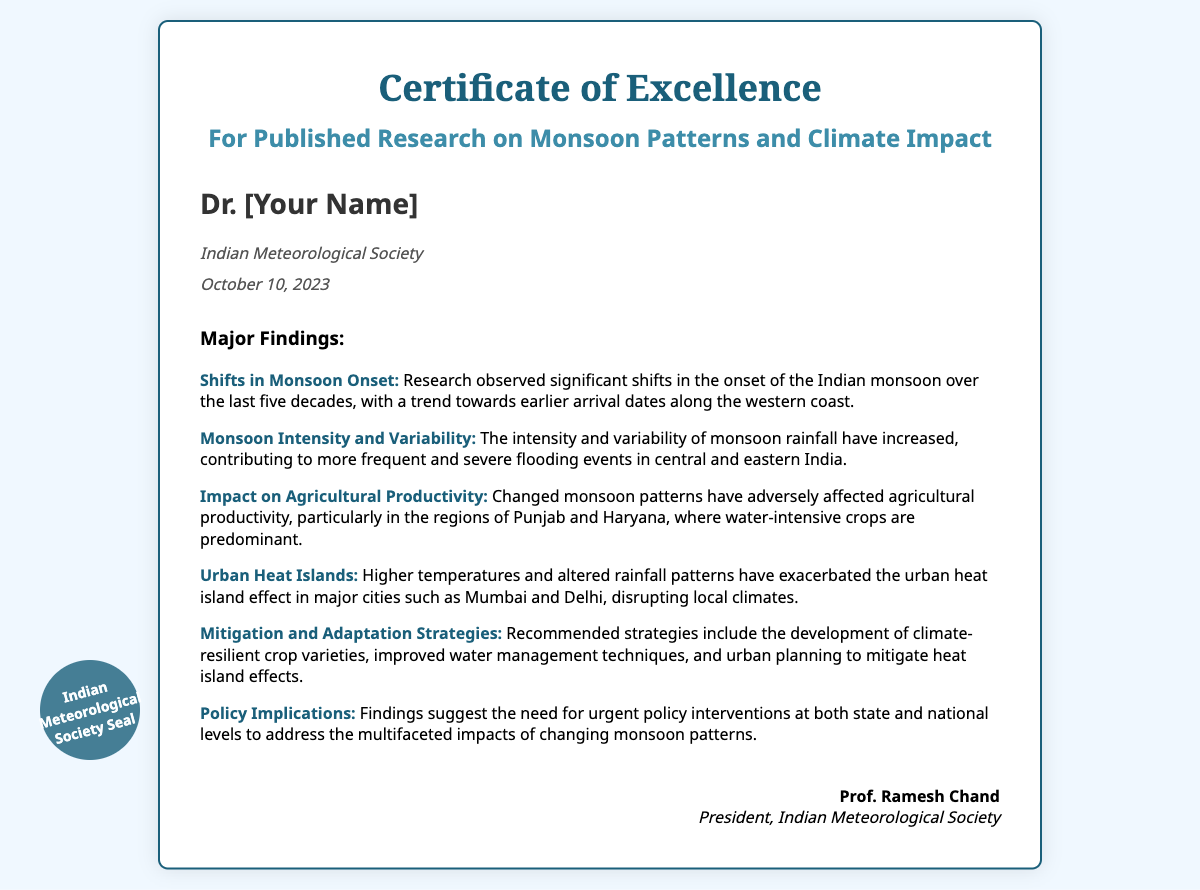What is the title of the certificate? The title of the certificate is prominently displayed at the top of the document, stating its purpose.
Answer: Certificate of Excellence Who is the recipient of the certificate? The recipient's name is clearly stated in the document, indicating who received the award.
Answer: Dr. [Your Name] What organization issued the certificate? The organization that issued the certificate is mentioned below the recipient's name.
Answer: Indian Meteorological Society What date was the certificate issued? The date of issuance is provided in the document, indicating when the certificate was given.
Answer: October 10, 2023 How many major findings are listed in the document? The total number of major findings can be counted from the numbered sections in the findings area.
Answer: Six What is one of the major findings regarding agricultural productivity? The findings section outlines specific impacts on agricultural productivity due to changed monsoon patterns.
Answer: Adversely affected in Punjab and Haryana What strategy is recommended for urban planning? The findings suggest specific strategies to mitigate urban climate effects.
Answer: Urban planning to mitigate heat island effects Who signed the certificate? The signature section provides the name of the individual who authorized the certificate.
Answer: Prof. Ramesh Chand What is the title of the signatory? The title of the person who signed the certificate is mentioned along with their name.
Answer: President, Indian Meteorological Society 